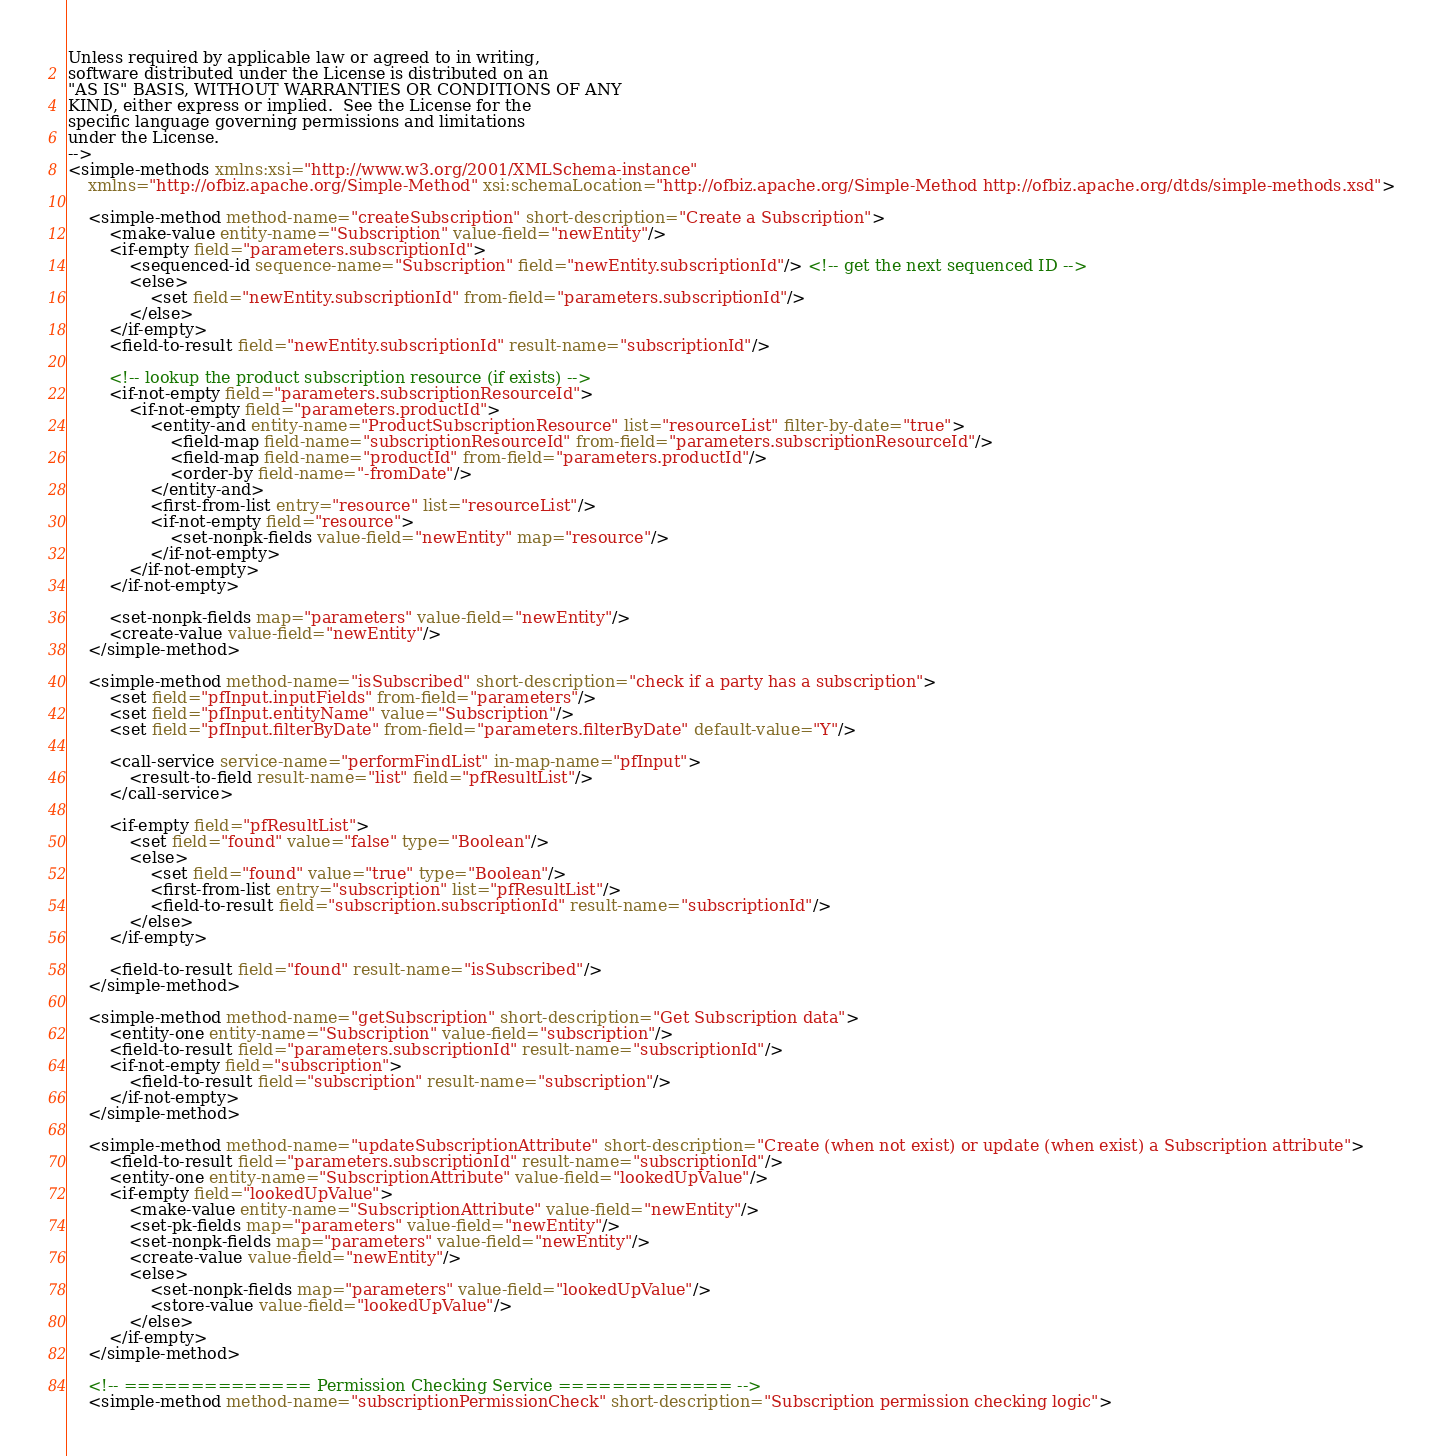Convert code to text. <code><loc_0><loc_0><loc_500><loc_500><_XML_>Unless required by applicable law or agreed to in writing,
software distributed under the License is distributed on an
"AS IS" BASIS, WITHOUT WARRANTIES OR CONDITIONS OF ANY
KIND, either express or implied.  See the License for the
specific language governing permissions and limitations
under the License.
-->
<simple-methods xmlns:xsi="http://www.w3.org/2001/XMLSchema-instance"
    xmlns="http://ofbiz.apache.org/Simple-Method" xsi:schemaLocation="http://ofbiz.apache.org/Simple-Method http://ofbiz.apache.org/dtds/simple-methods.xsd">

    <simple-method method-name="createSubscription" short-description="Create a Subscription">
        <make-value entity-name="Subscription" value-field="newEntity"/>
        <if-empty field="parameters.subscriptionId">
            <sequenced-id sequence-name="Subscription" field="newEntity.subscriptionId"/> <!-- get the next sequenced ID -->
            <else>
                <set field="newEntity.subscriptionId" from-field="parameters.subscriptionId"/>
            </else>
        </if-empty>
        <field-to-result field="newEntity.subscriptionId" result-name="subscriptionId"/>

        <!-- lookup the product subscription resource (if exists) -->
        <if-not-empty field="parameters.subscriptionResourceId">
            <if-not-empty field="parameters.productId">
                <entity-and entity-name="ProductSubscriptionResource" list="resourceList" filter-by-date="true">
                    <field-map field-name="subscriptionResourceId" from-field="parameters.subscriptionResourceId"/>
                    <field-map field-name="productId" from-field="parameters.productId"/>
                    <order-by field-name="-fromDate"/>
                </entity-and>
                <first-from-list entry="resource" list="resourceList"/>
                <if-not-empty field="resource">
                    <set-nonpk-fields value-field="newEntity" map="resource"/>
                </if-not-empty>
            </if-not-empty>
        </if-not-empty>

        <set-nonpk-fields map="parameters" value-field="newEntity"/>
        <create-value value-field="newEntity"/>
    </simple-method>

    <simple-method method-name="isSubscribed" short-description="check if a party has a subscription">
        <set field="pfInput.inputFields" from-field="parameters"/>
        <set field="pfInput.entityName" value="Subscription"/>
        <set field="pfInput.filterByDate" from-field="parameters.filterByDate" default-value="Y"/>

        <call-service service-name="performFindList" in-map-name="pfInput">
            <result-to-field result-name="list" field="pfResultList"/>
        </call-service>

        <if-empty field="pfResultList">
            <set field="found" value="false" type="Boolean"/>
            <else>
                <set field="found" value="true" type="Boolean"/>
                <first-from-list entry="subscription" list="pfResultList"/>
                <field-to-result field="subscription.subscriptionId" result-name="subscriptionId"/>
            </else>
        </if-empty>

        <field-to-result field="found" result-name="isSubscribed"/>
    </simple-method>

    <simple-method method-name="getSubscription" short-description="Get Subscription data">
        <entity-one entity-name="Subscription" value-field="subscription"/>
        <field-to-result field="parameters.subscriptionId" result-name="subscriptionId"/>
        <if-not-empty field="subscription">
            <field-to-result field="subscription" result-name="subscription"/>
        </if-not-empty>
    </simple-method>

    <simple-method method-name="updateSubscriptionAttribute" short-description="Create (when not exist) or update (when exist) a Subscription attribute">
        <field-to-result field="parameters.subscriptionId" result-name="subscriptionId"/>
        <entity-one entity-name="SubscriptionAttribute" value-field="lookedUpValue"/>
        <if-empty field="lookedUpValue">
            <make-value entity-name="SubscriptionAttribute" value-field="newEntity"/>
            <set-pk-fields map="parameters" value-field="newEntity"/>
            <set-nonpk-fields map="parameters" value-field="newEntity"/>
            <create-value value-field="newEntity"/>
            <else>
                <set-nonpk-fields map="parameters" value-field="lookedUpValue"/>
                <store-value value-field="lookedUpValue"/>
            </else>
        </if-empty>
    </simple-method>

    <!-- ============== Permission Checking Service ============= -->
    <simple-method method-name="subscriptionPermissionCheck" short-description="Subscription permission checking logic"></code> 